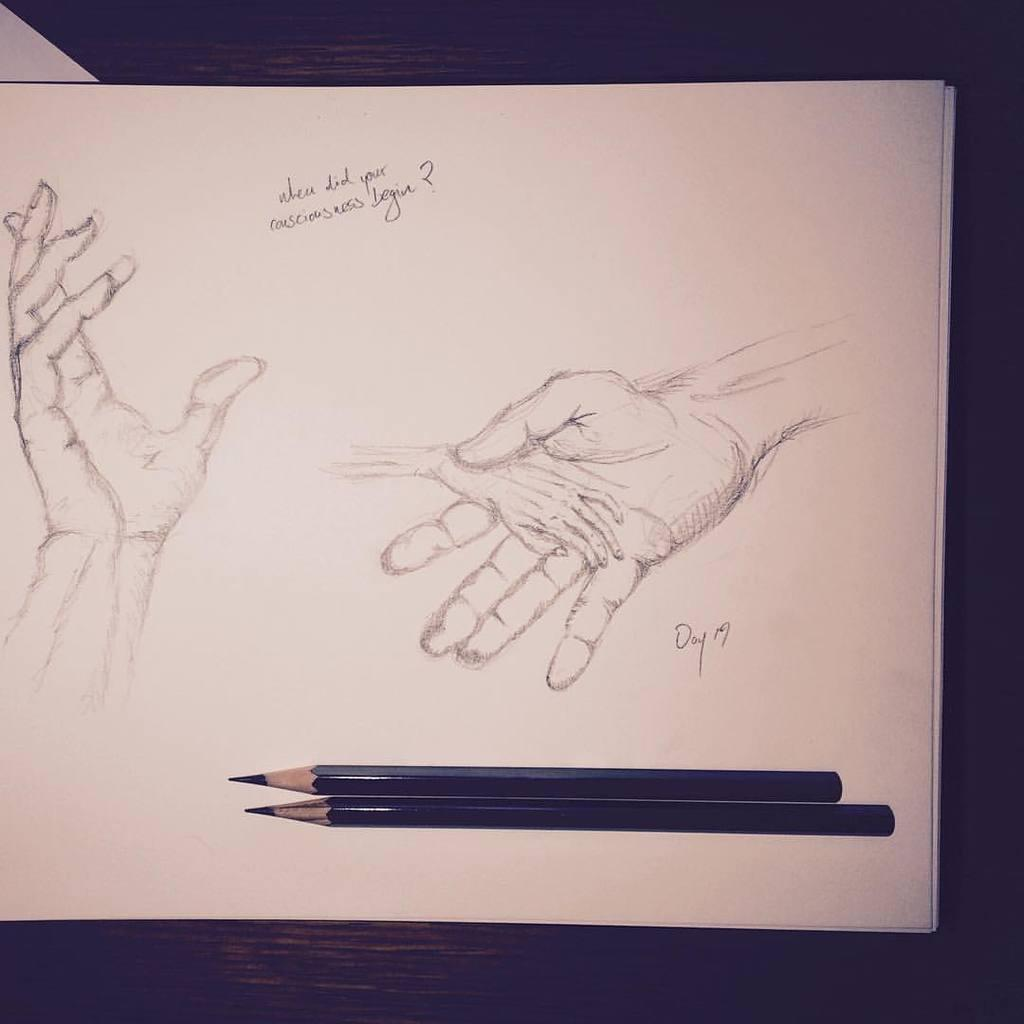What is depicted on the paper in the image? There is a sketch of human hands on the paper. What is the color of the paper? The paper is white in color. How many pencils are visible in the image? There are two pencils visible in the image. What can be observed about the background of the image? The background of the image is dark. What type of insurance policy is being discussed in the image? There is no discussion of insurance policies in the image; it features a sketch of human hands on a white paper with two visible pencils and a dark background. 